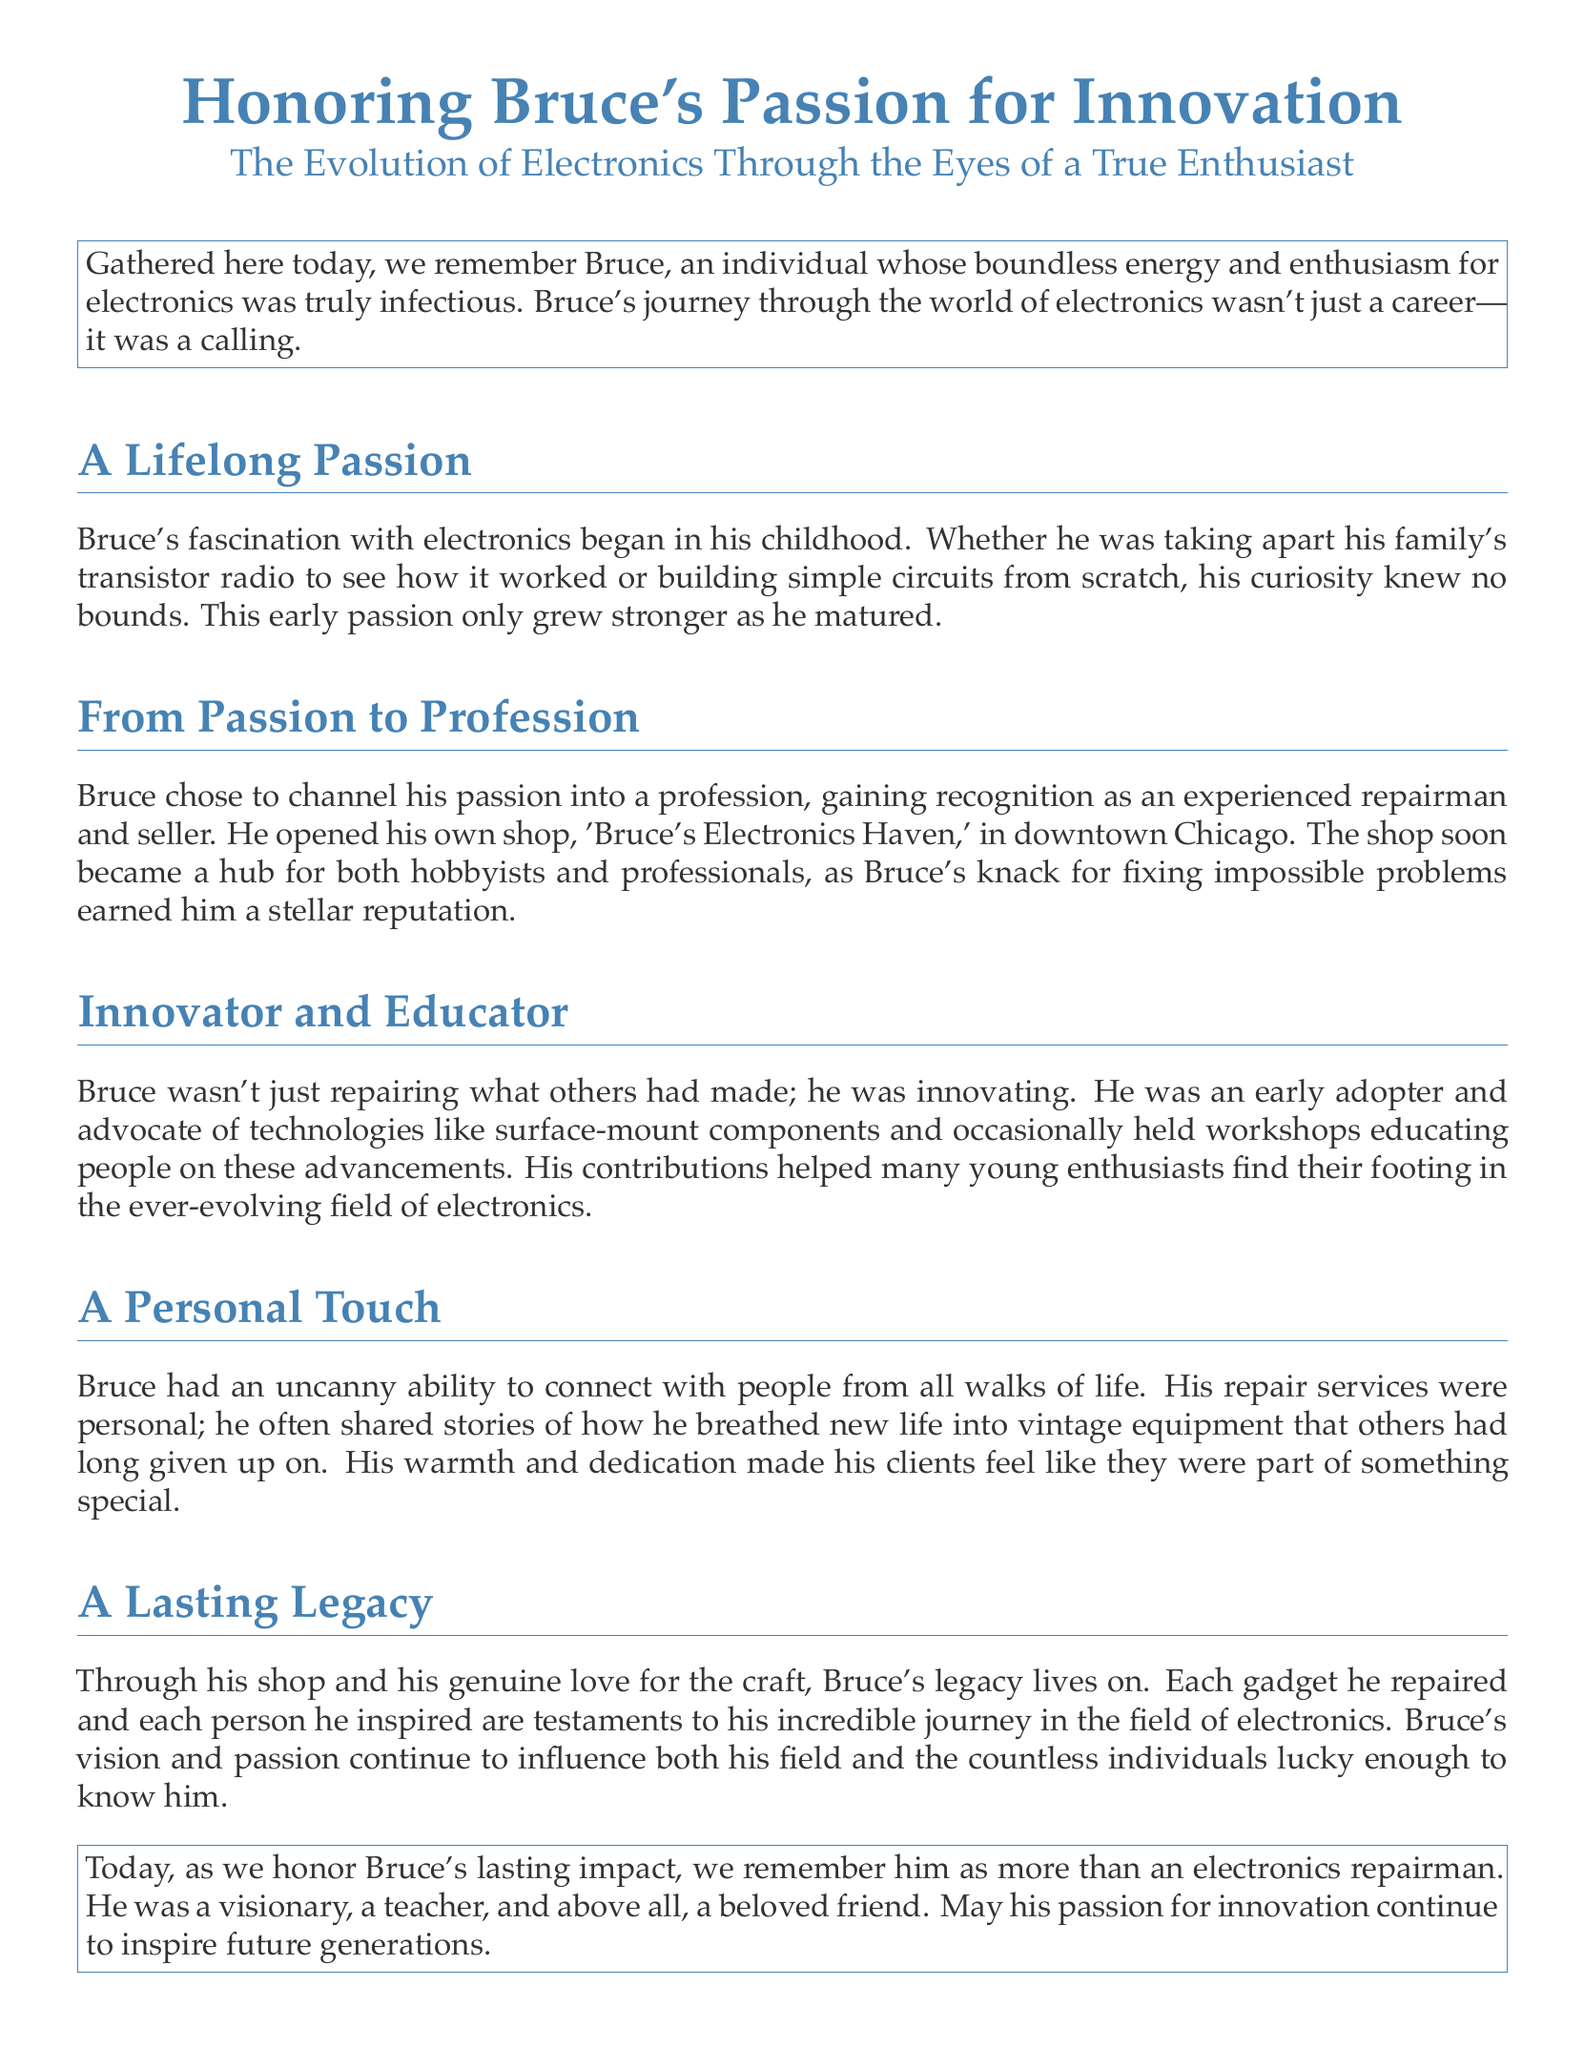Who was Bruce? Bruce was an individual whose boundless energy and enthusiasm for electronics was truly infectious.
Answer: Bruce What was the name of Bruce's shop? The document states the shop he opened was called 'Bruce's Electronics Haven.'
Answer: Bruce's Electronics Haven What city was Bruce's shop located in? According to the document, the shop was located in downtown Chicago.
Answer: Chicago What type of technology did Bruce advocate for? Bruce was an early adopter and advocate of surface-mount components.
Answer: surface-mount components What role did Bruce play in people's lives through his work? Bruce's work made his clients feel like they were part of something special.
Answer: special What was a significant aspect of Bruce's legacy? His legacy includes each gadget he repaired and each person he inspired.
Answer: legacy What was one of Bruce's activities outside of repairing? Bruce occasionally held workshops educating people on advancements in electronics.
Answer: workshops How did Bruce connect with others? He had an uncanny ability to connect with people from all walks of life.
Answer: connect What is stated as Bruce's true calling? Bruce's journey through the world of electronics was described as a calling.
Answer: calling 